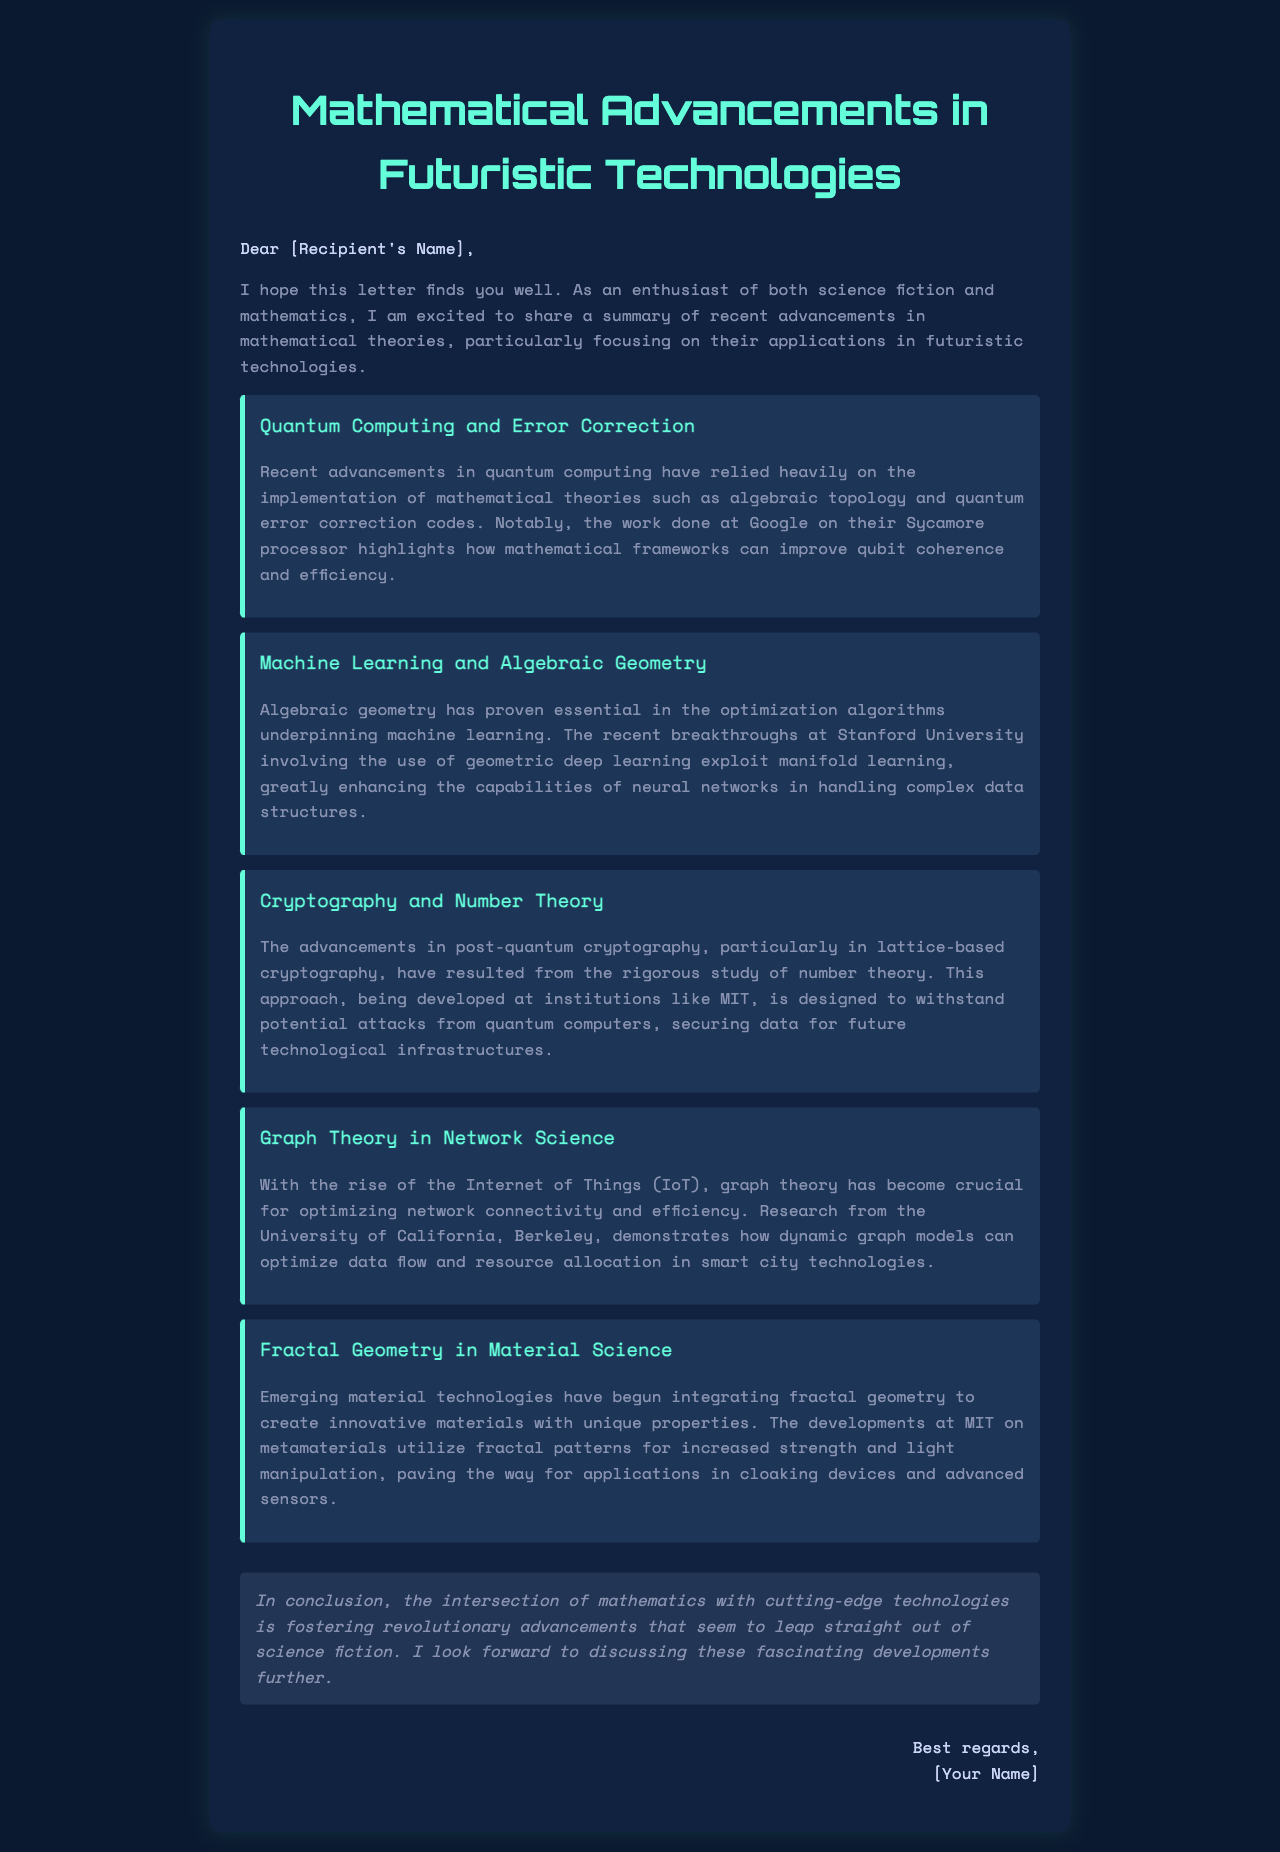What are the mathematical frameworks improving qubit coherence? The document mentions algebraic topology and quantum error correction codes as the mathematical frameworks related to quantum computing.
Answer: algebraic topology and quantum error correction codes Which university recently made breakthroughs in geometric deep learning? The letter states that recent breakthroughs were made at Stanford University involving geometric deep learning.
Answer: Stanford University What type of cryptography is being developed at MIT? The letter refers to advancements in post-quantum cryptography being developed at MIT, specifically in lattice-based cryptography.
Answer: lattice-based cryptography Which mathematical theory is crucial for optimizing network connectivity? According to the document, graph theory has become crucial for optimizing network connectivity and efficiency in network science.
Answer: graph theory What property do metamaterials developed at MIT utilize? The document states that the developments at MIT on metamaterials utilize fractal patterns for increased strength and light manipulation.
Answer: fractal patterns What overarching theme connects mathematics and futuristic technologies in the document? The letter indicates that the intersection of mathematics with cutting-edge technologies fosters revolutionary advancements.
Answer: revolutionary advancements 